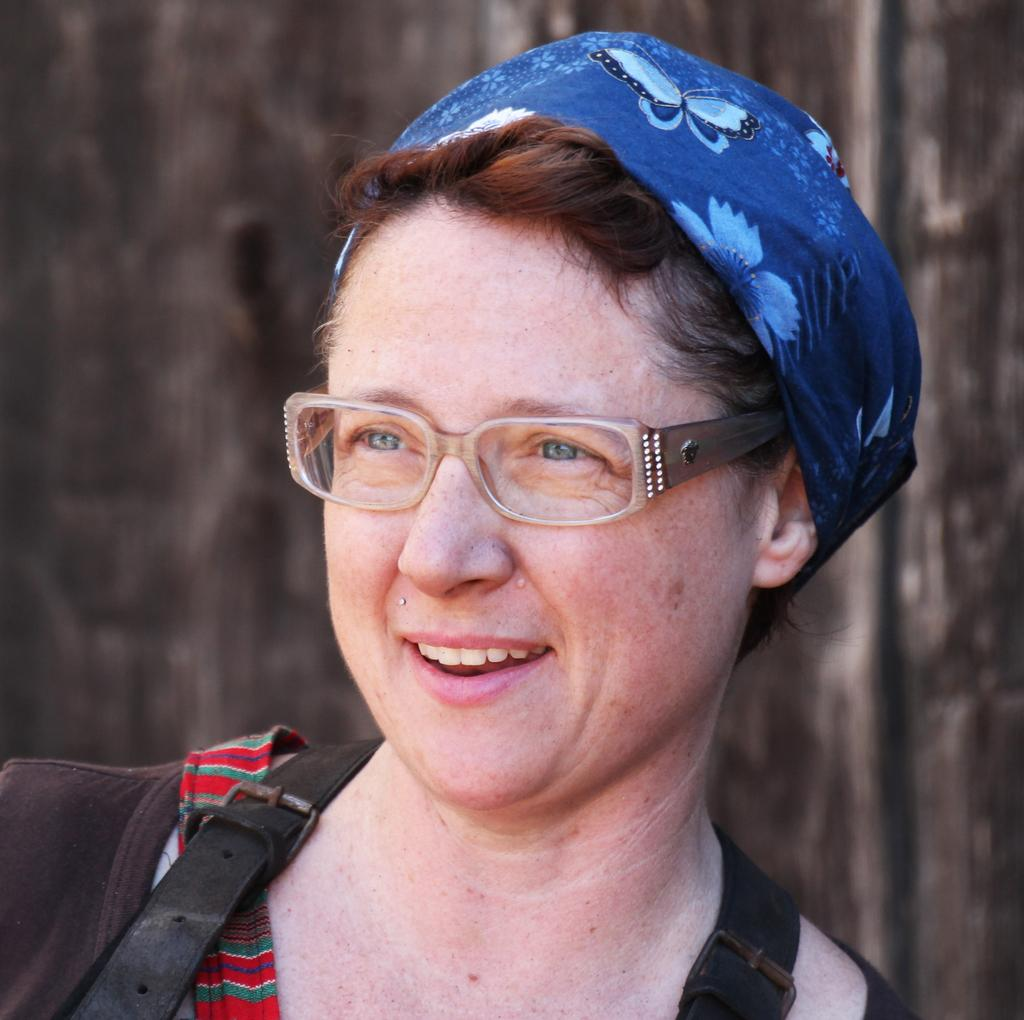What is the main subject of the image? There is a person standing in the image. Can you describe the person's attire? The person is wearing a blue cap. What accessory is the person wearing? The person is wearing spectacles. How would you describe the background of the image? The background of the image is blurred. What advice does the person's sister give in the image? There is no mention of a sister or any advice in the image. 